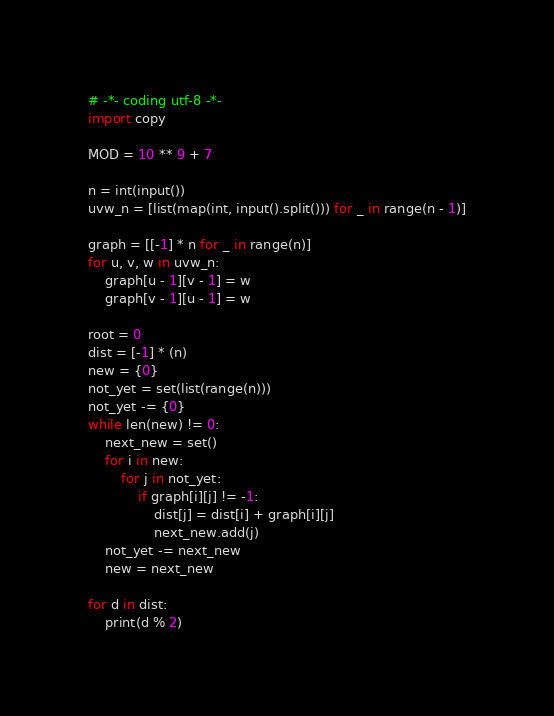Convert code to text. <code><loc_0><loc_0><loc_500><loc_500><_Python_># -*- coding utf-8 -*-
import copy

MOD = 10 ** 9 + 7

n = int(input())
uvw_n = [list(map(int, input().split())) for _ in range(n - 1)]

graph = [[-1] * n for _ in range(n)]
for u, v, w in uvw_n:
    graph[u - 1][v - 1] = w
    graph[v - 1][u - 1] = w

root = 0
dist = [-1] * (n)
new = {0}
not_yet = set(list(range(n)))
not_yet -= {0}
while len(new) != 0:
    next_new = set()
    for i in new:
        for j in not_yet:
            if graph[i][j] != -1:
                dist[j] = dist[i] + graph[i][j]
                next_new.add(j)
    not_yet -= next_new
    new = next_new

for d in dist:
    print(d % 2)

</code> 